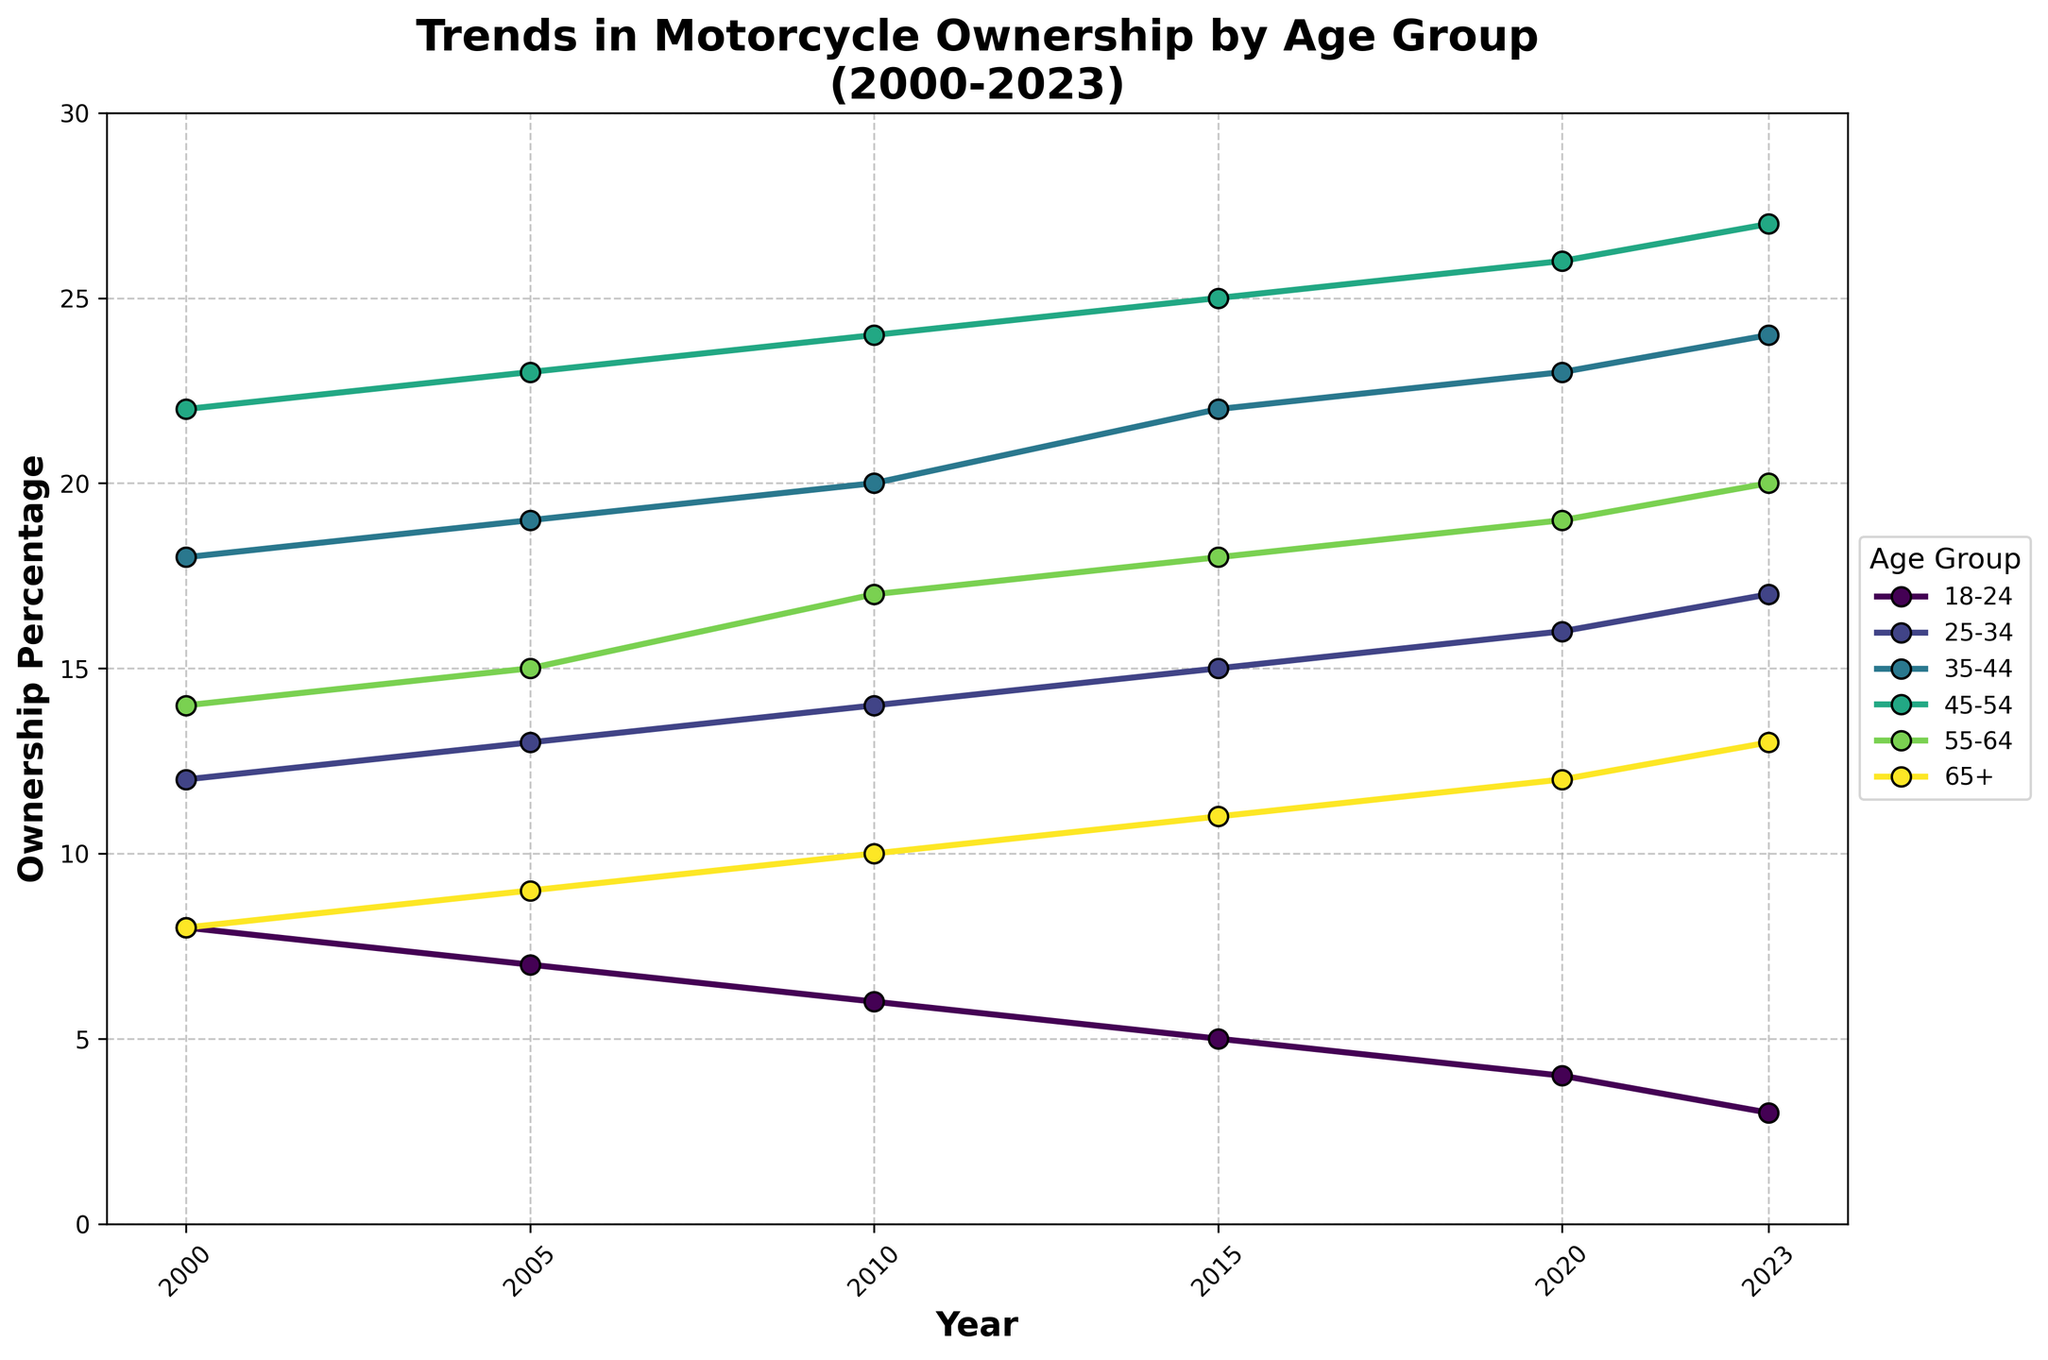What's the title of the figure? The title is usually displayed at the top of the figure. It often provides a concise summary of the data being shown. In this case, it is "Trends in Motorcycle Ownership by Age Group (2000-2023)".
Answer: Trends in Motorcycle Ownership by Age Group (2000-2023) What is the y-axis label? The y-axis label describes what the vertical axis represents. Here, it is "Ownership Percentage".
Answer: Ownership Percentage Which age group had the highest ownership percentage in 2023? Look at the endpoint of the lines in 2023 and identify the highest point. The 45-54 age group reaches the highest value in 2023.
Answer: 45-54 How did the ownership percentage trend for the 18-24 age group from 2000 to 2023? Trace the line corresponding to the 18-24 age group from 2000 to 2023. Notice that the value decreases consistently over the years.
Answer: Decreased What is the trend for the 25-34 age group from 2000 to 2023? Follow the 25-34 age group line from 2000 to 2023. The trend shows an overall increase in ownership percentage.
Answer: Increased Which age group saw the greatest increase in ownership percentage from 2000 to 2023? Calculate the difference between the ownership percentages in 2023 and 2000 for each age group. The 45-54 age group has the greatest increase, from 22% to 27%.
Answer: 45-54 In which year did the 55-64 age group see its first increase in ownership percentage? Track the ownership percentage values for the 55-64 age group. Identify the first year where the ownership percentage is higher than the previous year. This occurs between 2000 and 2005.
Answer: 2005 How many age groups had an ownership percentage greater than 20% in 2023? Check each age group's ownership percentage in 2023. The 35-44, 45-54, and 55-64 age groups have percentages greater than 20%. This sums up to three groups.
Answer: 3 Compare the ownership percentages of the 35-44 age group in 2000 and 2023. What is the absolute difference? Subtract the 2000 ownership percentage for the 35-44 age group from its 2023 value: 24% - 18% = 6%.
Answer: 6% By how many percentage points did the ownership percentage for the 65+ age group increase from 2000 to 2023? Find the difference in ownership percentage for the 65+ group between 2000 and 2023: 13% - 8% = 5%.
Answer: 5% 